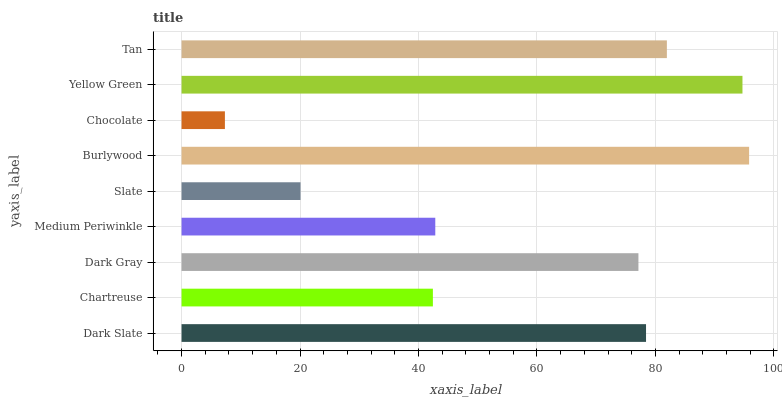Is Chocolate the minimum?
Answer yes or no. Yes. Is Burlywood the maximum?
Answer yes or no. Yes. Is Chartreuse the minimum?
Answer yes or no. No. Is Chartreuse the maximum?
Answer yes or no. No. Is Dark Slate greater than Chartreuse?
Answer yes or no. Yes. Is Chartreuse less than Dark Slate?
Answer yes or no. Yes. Is Chartreuse greater than Dark Slate?
Answer yes or no. No. Is Dark Slate less than Chartreuse?
Answer yes or no. No. Is Dark Gray the high median?
Answer yes or no. Yes. Is Dark Gray the low median?
Answer yes or no. Yes. Is Chocolate the high median?
Answer yes or no. No. Is Dark Slate the low median?
Answer yes or no. No. 